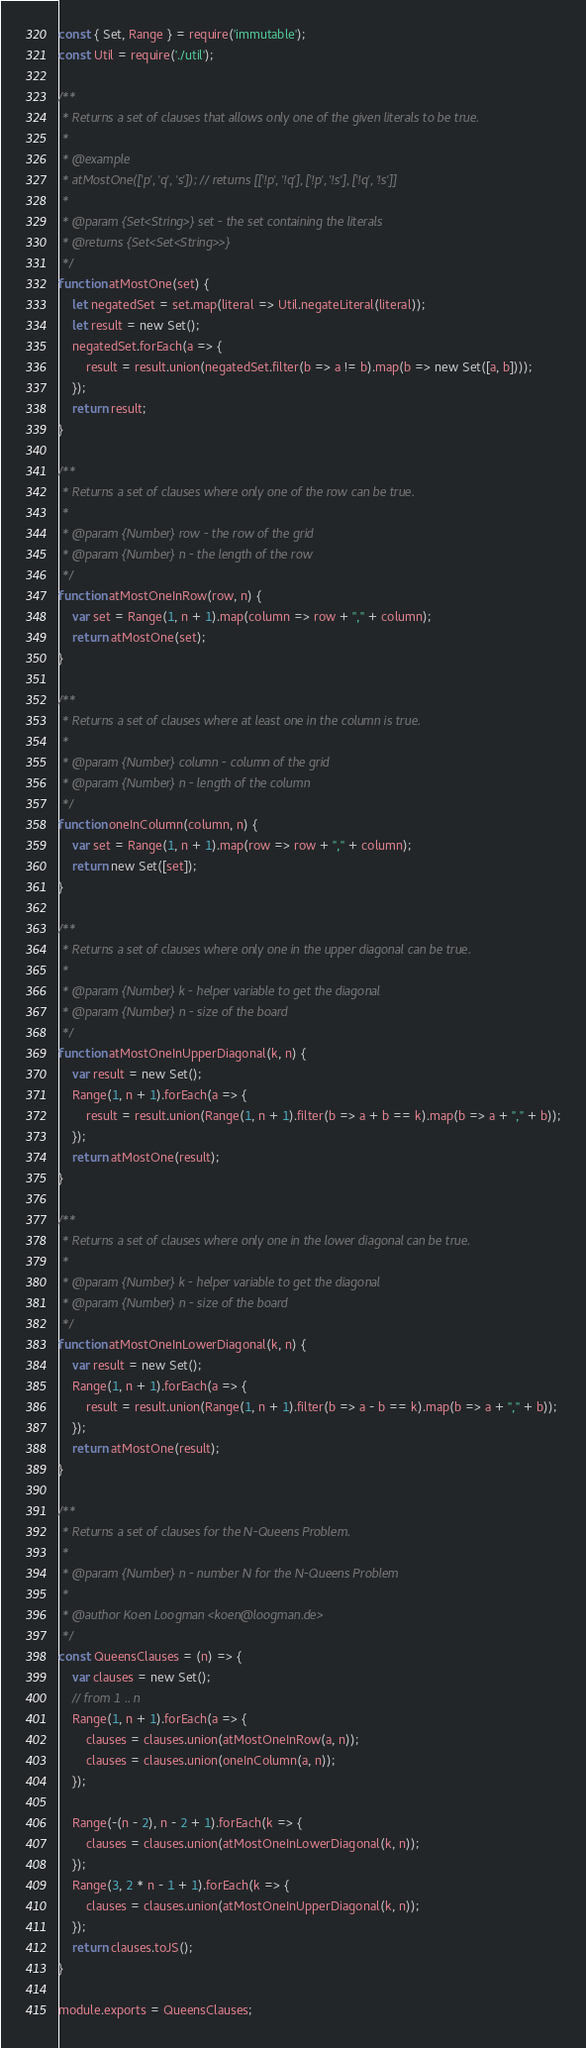<code> <loc_0><loc_0><loc_500><loc_500><_JavaScript_>const { Set, Range } = require('immutable');
const Util = require('./util');

/**
 * Returns a set of clauses that allows only one of the given literals to be true.
 * 
 * @example
 * atMostOne(['p', 'q', 's']); // returns [['!p', '!q'], ['!p', '!s'], ['!q', '!s']]
 * 
 * @param {Set<String>} set - the set containing the literals
 * @returns {Set<Set<String>>}
 */
function atMostOne(set) {
    let negatedSet = set.map(literal => Util.negateLiteral(literal));
    let result = new Set();
    negatedSet.forEach(a => {
        result = result.union(negatedSet.filter(b => a != b).map(b => new Set([a, b])));
    });
    return result;
}

/**
 * Returns a set of clauses where only one of the row can be true.
 * 
 * @param {Number} row - the row of the grid
 * @param {Number} n - the length of the row
 */
function atMostOneInRow(row, n) {
    var set = Range(1, n + 1).map(column => row + "," + column);
    return atMostOne(set);
}

/**
 * Returns a set of clauses where at least one in the column is true.
 * 
 * @param {Number} column - column of the grid
 * @param {Number} n - length of the column
 */
function oneInColumn(column, n) {
    var set = Range(1, n + 1).map(row => row + "," + column);
    return new Set([set]);
}

/**
 * Returns a set of clauses where only one in the upper diagonal can be true.
 * 
 * @param {Number} k - helper variable to get the diagonal
 * @param {Number} n - size of the board
 */
function atMostOneInUpperDiagonal(k, n) {
    var result = new Set();
    Range(1, n + 1).forEach(a => {
        result = result.union(Range(1, n + 1).filter(b => a + b == k).map(b => a + "," + b));
    });
    return atMostOne(result);
}

/**
 * Returns a set of clauses where only one in the lower diagonal can be true.
 * 
 * @param {Number} k - helper variable to get the diagonal
 * @param {Number} n - size of the board
 */
function atMostOneInLowerDiagonal(k, n) {
    var result = new Set();
    Range(1, n + 1).forEach(a => {
        result = result.union(Range(1, n + 1).filter(b => a - b == k).map(b => a + "," + b));
    });
    return atMostOne(result);
}

/**
 * Returns a set of clauses for the N-Queens Problem.
 * 
 * @param {Number} n - number N for the N-Queens Problem
 * 
 * @author Koen Loogman <koen@loogman.de>
 */
const QueensClauses = (n) => {
    var clauses = new Set();
    // from 1 .. n
    Range(1, n + 1).forEach(a => {
        clauses = clauses.union(atMostOneInRow(a, n));
        clauses = clauses.union(oneInColumn(a, n));
    });

    Range(-(n - 2), n - 2 + 1).forEach(k => {
        clauses = clauses.union(atMostOneInLowerDiagonal(k, n));
    });
    Range(3, 2 * n - 1 + 1).forEach(k => {
        clauses = clauses.union(atMostOneInUpperDiagonal(k, n));
    });
    return clauses.toJS();
}

module.exports = QueensClauses;</code> 